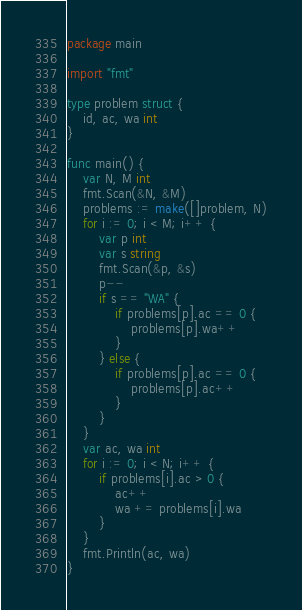Convert code to text. <code><loc_0><loc_0><loc_500><loc_500><_Go_>package main

import "fmt"

type problem struct {
	id, ac, wa int
}

func main() {
	var N, M int
	fmt.Scan(&N, &M)
	problems := make([]problem, N)
	for i := 0; i < M; i++ {
		var p int
		var s string
		fmt.Scan(&p, &s)
		p--
		if s == "WA" {
			if problems[p].ac == 0 {
				problems[p].wa++
			}
		} else {
			if problems[p].ac == 0 {
				problems[p].ac++
			}
		}
	}
	var ac, wa int
	for i := 0; i < N; i++ {
		if problems[i].ac > 0 {
			ac++
			wa += problems[i].wa
		}
	}
	fmt.Println(ac, wa)
}
</code> 